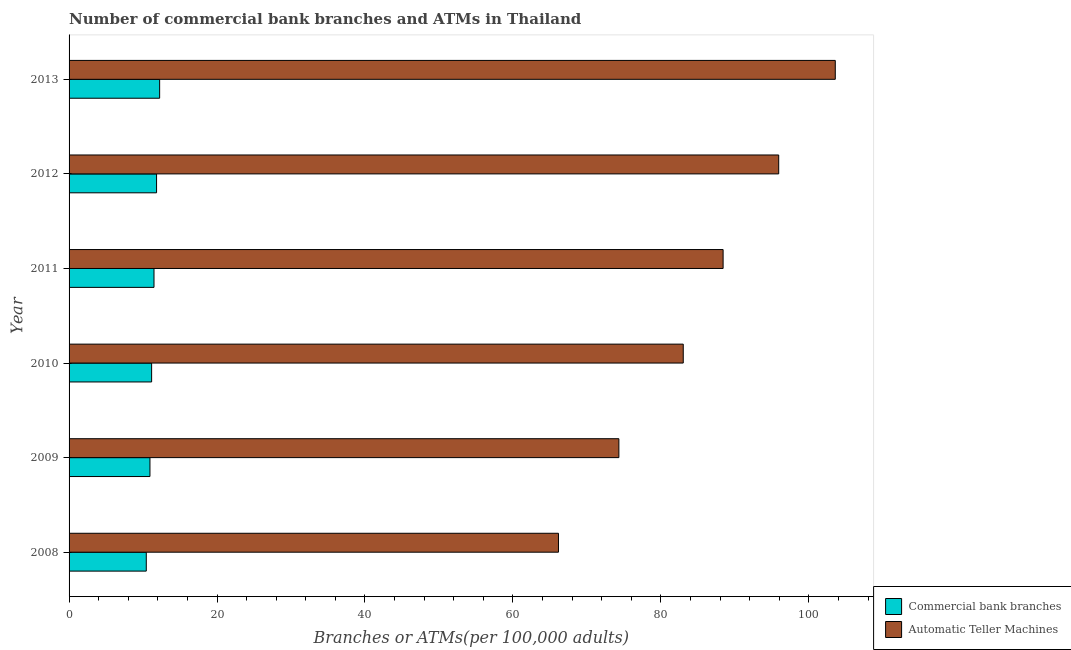How many different coloured bars are there?
Keep it short and to the point. 2. Are the number of bars on each tick of the Y-axis equal?
Provide a succinct answer. Yes. How many bars are there on the 5th tick from the top?
Offer a very short reply. 2. What is the number of atms in 2011?
Your answer should be very brief. 88.41. Across all years, what is the maximum number of atms?
Your response must be concise. 103.57. Across all years, what is the minimum number of commercal bank branches?
Your answer should be compact. 10.44. In which year was the number of commercal bank branches maximum?
Give a very brief answer. 2013. What is the total number of atms in the graph?
Ensure brevity in your answer.  511.39. What is the difference between the number of atms in 2010 and that in 2012?
Provide a short and direct response. -12.9. What is the difference between the number of commercal bank branches in 2010 and the number of atms in 2012?
Your answer should be very brief. -84.76. What is the average number of commercal bank branches per year?
Offer a very short reply. 11.35. In the year 2012, what is the difference between the number of atms and number of commercal bank branches?
Your response must be concise. 84.1. What is the ratio of the number of atms in 2008 to that in 2010?
Your answer should be compact. 0.8. Is the number of commercal bank branches in 2011 less than that in 2012?
Offer a very short reply. Yes. Is the difference between the number of atms in 2009 and 2010 greater than the difference between the number of commercal bank branches in 2009 and 2010?
Your response must be concise. No. What is the difference between the highest and the second highest number of atms?
Offer a terse response. 7.65. What is the difference between the highest and the lowest number of atms?
Ensure brevity in your answer.  37.42. In how many years, is the number of commercal bank branches greater than the average number of commercal bank branches taken over all years?
Ensure brevity in your answer.  3. What does the 1st bar from the top in 2012 represents?
Your response must be concise. Automatic Teller Machines. What does the 1st bar from the bottom in 2010 represents?
Give a very brief answer. Commercial bank branches. How many years are there in the graph?
Provide a succinct answer. 6. What is the difference between two consecutive major ticks on the X-axis?
Your answer should be compact. 20. Are the values on the major ticks of X-axis written in scientific E-notation?
Keep it short and to the point. No. What is the title of the graph?
Provide a short and direct response. Number of commercial bank branches and ATMs in Thailand. Does "Food" appear as one of the legend labels in the graph?
Your answer should be compact. No. What is the label or title of the X-axis?
Your answer should be compact. Branches or ATMs(per 100,0 adults). What is the Branches or ATMs(per 100,000 adults) in Commercial bank branches in 2008?
Make the answer very short. 10.44. What is the Branches or ATMs(per 100,000 adults) of Automatic Teller Machines in 2008?
Make the answer very short. 66.15. What is the Branches or ATMs(per 100,000 adults) of Commercial bank branches in 2009?
Provide a short and direct response. 10.93. What is the Branches or ATMs(per 100,000 adults) of Automatic Teller Machines in 2009?
Provide a succinct answer. 74.32. What is the Branches or ATMs(per 100,000 adults) of Commercial bank branches in 2010?
Give a very brief answer. 11.16. What is the Branches or ATMs(per 100,000 adults) of Automatic Teller Machines in 2010?
Offer a very short reply. 83.02. What is the Branches or ATMs(per 100,000 adults) in Commercial bank branches in 2011?
Your answer should be compact. 11.48. What is the Branches or ATMs(per 100,000 adults) of Automatic Teller Machines in 2011?
Your answer should be very brief. 88.41. What is the Branches or ATMs(per 100,000 adults) of Commercial bank branches in 2012?
Your response must be concise. 11.83. What is the Branches or ATMs(per 100,000 adults) in Automatic Teller Machines in 2012?
Make the answer very short. 95.92. What is the Branches or ATMs(per 100,000 adults) of Commercial bank branches in 2013?
Provide a short and direct response. 12.24. What is the Branches or ATMs(per 100,000 adults) of Automatic Teller Machines in 2013?
Make the answer very short. 103.57. Across all years, what is the maximum Branches or ATMs(per 100,000 adults) in Commercial bank branches?
Ensure brevity in your answer.  12.24. Across all years, what is the maximum Branches or ATMs(per 100,000 adults) in Automatic Teller Machines?
Ensure brevity in your answer.  103.57. Across all years, what is the minimum Branches or ATMs(per 100,000 adults) in Commercial bank branches?
Make the answer very short. 10.44. Across all years, what is the minimum Branches or ATMs(per 100,000 adults) in Automatic Teller Machines?
Offer a very short reply. 66.15. What is the total Branches or ATMs(per 100,000 adults) of Commercial bank branches in the graph?
Make the answer very short. 68.08. What is the total Branches or ATMs(per 100,000 adults) in Automatic Teller Machines in the graph?
Provide a succinct answer. 511.39. What is the difference between the Branches or ATMs(per 100,000 adults) of Commercial bank branches in 2008 and that in 2009?
Your response must be concise. -0.5. What is the difference between the Branches or ATMs(per 100,000 adults) of Automatic Teller Machines in 2008 and that in 2009?
Offer a very short reply. -8.17. What is the difference between the Branches or ATMs(per 100,000 adults) in Commercial bank branches in 2008 and that in 2010?
Your answer should be compact. -0.72. What is the difference between the Branches or ATMs(per 100,000 adults) of Automatic Teller Machines in 2008 and that in 2010?
Give a very brief answer. -16.87. What is the difference between the Branches or ATMs(per 100,000 adults) of Commercial bank branches in 2008 and that in 2011?
Offer a terse response. -1.04. What is the difference between the Branches or ATMs(per 100,000 adults) of Automatic Teller Machines in 2008 and that in 2011?
Ensure brevity in your answer.  -22.26. What is the difference between the Branches or ATMs(per 100,000 adults) in Commercial bank branches in 2008 and that in 2012?
Give a very brief answer. -1.39. What is the difference between the Branches or ATMs(per 100,000 adults) of Automatic Teller Machines in 2008 and that in 2012?
Give a very brief answer. -29.77. What is the difference between the Branches or ATMs(per 100,000 adults) of Commercial bank branches in 2008 and that in 2013?
Keep it short and to the point. -1.81. What is the difference between the Branches or ATMs(per 100,000 adults) of Automatic Teller Machines in 2008 and that in 2013?
Provide a short and direct response. -37.42. What is the difference between the Branches or ATMs(per 100,000 adults) in Commercial bank branches in 2009 and that in 2010?
Your answer should be very brief. -0.22. What is the difference between the Branches or ATMs(per 100,000 adults) of Automatic Teller Machines in 2009 and that in 2010?
Provide a succinct answer. -8.7. What is the difference between the Branches or ATMs(per 100,000 adults) in Commercial bank branches in 2009 and that in 2011?
Give a very brief answer. -0.55. What is the difference between the Branches or ATMs(per 100,000 adults) of Automatic Teller Machines in 2009 and that in 2011?
Provide a short and direct response. -14.09. What is the difference between the Branches or ATMs(per 100,000 adults) of Commercial bank branches in 2009 and that in 2012?
Provide a succinct answer. -0.89. What is the difference between the Branches or ATMs(per 100,000 adults) of Automatic Teller Machines in 2009 and that in 2012?
Your answer should be very brief. -21.6. What is the difference between the Branches or ATMs(per 100,000 adults) in Commercial bank branches in 2009 and that in 2013?
Provide a short and direct response. -1.31. What is the difference between the Branches or ATMs(per 100,000 adults) of Automatic Teller Machines in 2009 and that in 2013?
Keep it short and to the point. -29.25. What is the difference between the Branches or ATMs(per 100,000 adults) of Commercial bank branches in 2010 and that in 2011?
Your response must be concise. -0.32. What is the difference between the Branches or ATMs(per 100,000 adults) of Automatic Teller Machines in 2010 and that in 2011?
Offer a terse response. -5.39. What is the difference between the Branches or ATMs(per 100,000 adults) in Commercial bank branches in 2010 and that in 2012?
Ensure brevity in your answer.  -0.67. What is the difference between the Branches or ATMs(per 100,000 adults) in Automatic Teller Machines in 2010 and that in 2012?
Your response must be concise. -12.9. What is the difference between the Branches or ATMs(per 100,000 adults) in Commercial bank branches in 2010 and that in 2013?
Offer a very short reply. -1.08. What is the difference between the Branches or ATMs(per 100,000 adults) of Automatic Teller Machines in 2010 and that in 2013?
Your answer should be very brief. -20.55. What is the difference between the Branches or ATMs(per 100,000 adults) in Commercial bank branches in 2011 and that in 2012?
Provide a succinct answer. -0.35. What is the difference between the Branches or ATMs(per 100,000 adults) of Automatic Teller Machines in 2011 and that in 2012?
Offer a very short reply. -7.51. What is the difference between the Branches or ATMs(per 100,000 adults) of Commercial bank branches in 2011 and that in 2013?
Offer a terse response. -0.76. What is the difference between the Branches or ATMs(per 100,000 adults) of Automatic Teller Machines in 2011 and that in 2013?
Give a very brief answer. -15.16. What is the difference between the Branches or ATMs(per 100,000 adults) of Commercial bank branches in 2012 and that in 2013?
Keep it short and to the point. -0.42. What is the difference between the Branches or ATMs(per 100,000 adults) in Automatic Teller Machines in 2012 and that in 2013?
Give a very brief answer. -7.65. What is the difference between the Branches or ATMs(per 100,000 adults) of Commercial bank branches in 2008 and the Branches or ATMs(per 100,000 adults) of Automatic Teller Machines in 2009?
Offer a terse response. -63.88. What is the difference between the Branches or ATMs(per 100,000 adults) in Commercial bank branches in 2008 and the Branches or ATMs(per 100,000 adults) in Automatic Teller Machines in 2010?
Offer a terse response. -72.58. What is the difference between the Branches or ATMs(per 100,000 adults) in Commercial bank branches in 2008 and the Branches or ATMs(per 100,000 adults) in Automatic Teller Machines in 2011?
Your answer should be compact. -77.97. What is the difference between the Branches or ATMs(per 100,000 adults) in Commercial bank branches in 2008 and the Branches or ATMs(per 100,000 adults) in Automatic Teller Machines in 2012?
Keep it short and to the point. -85.49. What is the difference between the Branches or ATMs(per 100,000 adults) in Commercial bank branches in 2008 and the Branches or ATMs(per 100,000 adults) in Automatic Teller Machines in 2013?
Give a very brief answer. -93.13. What is the difference between the Branches or ATMs(per 100,000 adults) in Commercial bank branches in 2009 and the Branches or ATMs(per 100,000 adults) in Automatic Teller Machines in 2010?
Offer a very short reply. -72.09. What is the difference between the Branches or ATMs(per 100,000 adults) of Commercial bank branches in 2009 and the Branches or ATMs(per 100,000 adults) of Automatic Teller Machines in 2011?
Keep it short and to the point. -77.47. What is the difference between the Branches or ATMs(per 100,000 adults) in Commercial bank branches in 2009 and the Branches or ATMs(per 100,000 adults) in Automatic Teller Machines in 2012?
Your response must be concise. -84.99. What is the difference between the Branches or ATMs(per 100,000 adults) in Commercial bank branches in 2009 and the Branches or ATMs(per 100,000 adults) in Automatic Teller Machines in 2013?
Your answer should be compact. -92.64. What is the difference between the Branches or ATMs(per 100,000 adults) of Commercial bank branches in 2010 and the Branches or ATMs(per 100,000 adults) of Automatic Teller Machines in 2011?
Keep it short and to the point. -77.25. What is the difference between the Branches or ATMs(per 100,000 adults) of Commercial bank branches in 2010 and the Branches or ATMs(per 100,000 adults) of Automatic Teller Machines in 2012?
Your response must be concise. -84.76. What is the difference between the Branches or ATMs(per 100,000 adults) of Commercial bank branches in 2010 and the Branches or ATMs(per 100,000 adults) of Automatic Teller Machines in 2013?
Keep it short and to the point. -92.41. What is the difference between the Branches or ATMs(per 100,000 adults) in Commercial bank branches in 2011 and the Branches or ATMs(per 100,000 adults) in Automatic Teller Machines in 2012?
Offer a terse response. -84.44. What is the difference between the Branches or ATMs(per 100,000 adults) of Commercial bank branches in 2011 and the Branches or ATMs(per 100,000 adults) of Automatic Teller Machines in 2013?
Keep it short and to the point. -92.09. What is the difference between the Branches or ATMs(per 100,000 adults) in Commercial bank branches in 2012 and the Branches or ATMs(per 100,000 adults) in Automatic Teller Machines in 2013?
Offer a very short reply. -91.74. What is the average Branches or ATMs(per 100,000 adults) in Commercial bank branches per year?
Make the answer very short. 11.35. What is the average Branches or ATMs(per 100,000 adults) of Automatic Teller Machines per year?
Provide a short and direct response. 85.23. In the year 2008, what is the difference between the Branches or ATMs(per 100,000 adults) in Commercial bank branches and Branches or ATMs(per 100,000 adults) in Automatic Teller Machines?
Offer a very short reply. -55.72. In the year 2009, what is the difference between the Branches or ATMs(per 100,000 adults) of Commercial bank branches and Branches or ATMs(per 100,000 adults) of Automatic Teller Machines?
Your answer should be very brief. -63.38. In the year 2010, what is the difference between the Branches or ATMs(per 100,000 adults) of Commercial bank branches and Branches or ATMs(per 100,000 adults) of Automatic Teller Machines?
Offer a very short reply. -71.86. In the year 2011, what is the difference between the Branches or ATMs(per 100,000 adults) in Commercial bank branches and Branches or ATMs(per 100,000 adults) in Automatic Teller Machines?
Provide a succinct answer. -76.93. In the year 2012, what is the difference between the Branches or ATMs(per 100,000 adults) of Commercial bank branches and Branches or ATMs(per 100,000 adults) of Automatic Teller Machines?
Keep it short and to the point. -84.1. In the year 2013, what is the difference between the Branches or ATMs(per 100,000 adults) in Commercial bank branches and Branches or ATMs(per 100,000 adults) in Automatic Teller Machines?
Offer a very short reply. -91.33. What is the ratio of the Branches or ATMs(per 100,000 adults) in Commercial bank branches in 2008 to that in 2009?
Your answer should be very brief. 0.95. What is the ratio of the Branches or ATMs(per 100,000 adults) in Automatic Teller Machines in 2008 to that in 2009?
Provide a short and direct response. 0.89. What is the ratio of the Branches or ATMs(per 100,000 adults) in Commercial bank branches in 2008 to that in 2010?
Ensure brevity in your answer.  0.94. What is the ratio of the Branches or ATMs(per 100,000 adults) in Automatic Teller Machines in 2008 to that in 2010?
Provide a short and direct response. 0.8. What is the ratio of the Branches or ATMs(per 100,000 adults) in Automatic Teller Machines in 2008 to that in 2011?
Your response must be concise. 0.75. What is the ratio of the Branches or ATMs(per 100,000 adults) in Commercial bank branches in 2008 to that in 2012?
Give a very brief answer. 0.88. What is the ratio of the Branches or ATMs(per 100,000 adults) of Automatic Teller Machines in 2008 to that in 2012?
Offer a very short reply. 0.69. What is the ratio of the Branches or ATMs(per 100,000 adults) in Commercial bank branches in 2008 to that in 2013?
Offer a terse response. 0.85. What is the ratio of the Branches or ATMs(per 100,000 adults) of Automatic Teller Machines in 2008 to that in 2013?
Give a very brief answer. 0.64. What is the ratio of the Branches or ATMs(per 100,000 adults) of Commercial bank branches in 2009 to that in 2010?
Your answer should be compact. 0.98. What is the ratio of the Branches or ATMs(per 100,000 adults) of Automatic Teller Machines in 2009 to that in 2010?
Give a very brief answer. 0.9. What is the ratio of the Branches or ATMs(per 100,000 adults) in Commercial bank branches in 2009 to that in 2011?
Your answer should be compact. 0.95. What is the ratio of the Branches or ATMs(per 100,000 adults) in Automatic Teller Machines in 2009 to that in 2011?
Provide a short and direct response. 0.84. What is the ratio of the Branches or ATMs(per 100,000 adults) in Commercial bank branches in 2009 to that in 2012?
Your answer should be very brief. 0.92. What is the ratio of the Branches or ATMs(per 100,000 adults) of Automatic Teller Machines in 2009 to that in 2012?
Keep it short and to the point. 0.77. What is the ratio of the Branches or ATMs(per 100,000 adults) in Commercial bank branches in 2009 to that in 2013?
Provide a succinct answer. 0.89. What is the ratio of the Branches or ATMs(per 100,000 adults) in Automatic Teller Machines in 2009 to that in 2013?
Make the answer very short. 0.72. What is the ratio of the Branches or ATMs(per 100,000 adults) in Automatic Teller Machines in 2010 to that in 2011?
Your answer should be very brief. 0.94. What is the ratio of the Branches or ATMs(per 100,000 adults) in Commercial bank branches in 2010 to that in 2012?
Offer a very short reply. 0.94. What is the ratio of the Branches or ATMs(per 100,000 adults) of Automatic Teller Machines in 2010 to that in 2012?
Give a very brief answer. 0.87. What is the ratio of the Branches or ATMs(per 100,000 adults) in Commercial bank branches in 2010 to that in 2013?
Provide a short and direct response. 0.91. What is the ratio of the Branches or ATMs(per 100,000 adults) of Automatic Teller Machines in 2010 to that in 2013?
Ensure brevity in your answer.  0.8. What is the ratio of the Branches or ATMs(per 100,000 adults) of Commercial bank branches in 2011 to that in 2012?
Your answer should be compact. 0.97. What is the ratio of the Branches or ATMs(per 100,000 adults) of Automatic Teller Machines in 2011 to that in 2012?
Offer a terse response. 0.92. What is the ratio of the Branches or ATMs(per 100,000 adults) in Commercial bank branches in 2011 to that in 2013?
Make the answer very short. 0.94. What is the ratio of the Branches or ATMs(per 100,000 adults) in Automatic Teller Machines in 2011 to that in 2013?
Your answer should be very brief. 0.85. What is the ratio of the Branches or ATMs(per 100,000 adults) in Commercial bank branches in 2012 to that in 2013?
Keep it short and to the point. 0.97. What is the ratio of the Branches or ATMs(per 100,000 adults) of Automatic Teller Machines in 2012 to that in 2013?
Keep it short and to the point. 0.93. What is the difference between the highest and the second highest Branches or ATMs(per 100,000 adults) of Commercial bank branches?
Your response must be concise. 0.42. What is the difference between the highest and the second highest Branches or ATMs(per 100,000 adults) in Automatic Teller Machines?
Your answer should be compact. 7.65. What is the difference between the highest and the lowest Branches or ATMs(per 100,000 adults) in Commercial bank branches?
Your answer should be very brief. 1.81. What is the difference between the highest and the lowest Branches or ATMs(per 100,000 adults) of Automatic Teller Machines?
Your answer should be compact. 37.42. 